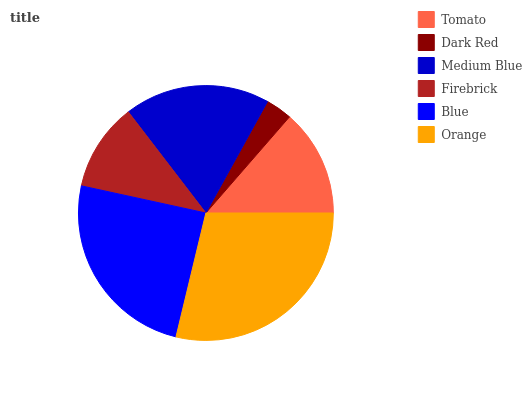Is Dark Red the minimum?
Answer yes or no. Yes. Is Orange the maximum?
Answer yes or no. Yes. Is Medium Blue the minimum?
Answer yes or no. No. Is Medium Blue the maximum?
Answer yes or no. No. Is Medium Blue greater than Dark Red?
Answer yes or no. Yes. Is Dark Red less than Medium Blue?
Answer yes or no. Yes. Is Dark Red greater than Medium Blue?
Answer yes or no. No. Is Medium Blue less than Dark Red?
Answer yes or no. No. Is Medium Blue the high median?
Answer yes or no. Yes. Is Tomato the low median?
Answer yes or no. Yes. Is Tomato the high median?
Answer yes or no. No. Is Orange the low median?
Answer yes or no. No. 